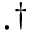Convert formula to latex. <formula><loc_0><loc_0><loc_500><loc_500>\cdot ^ { \dagger }</formula> 